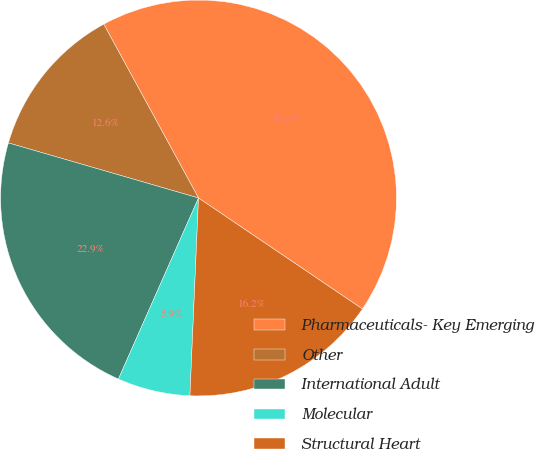Convert chart. <chart><loc_0><loc_0><loc_500><loc_500><pie_chart><fcel>Pharmaceuticals- Key Emerging<fcel>Other<fcel>International Adult<fcel>Molecular<fcel>Structural Heart<nl><fcel>42.42%<fcel>12.57%<fcel>22.86%<fcel>5.94%<fcel>16.22%<nl></chart> 